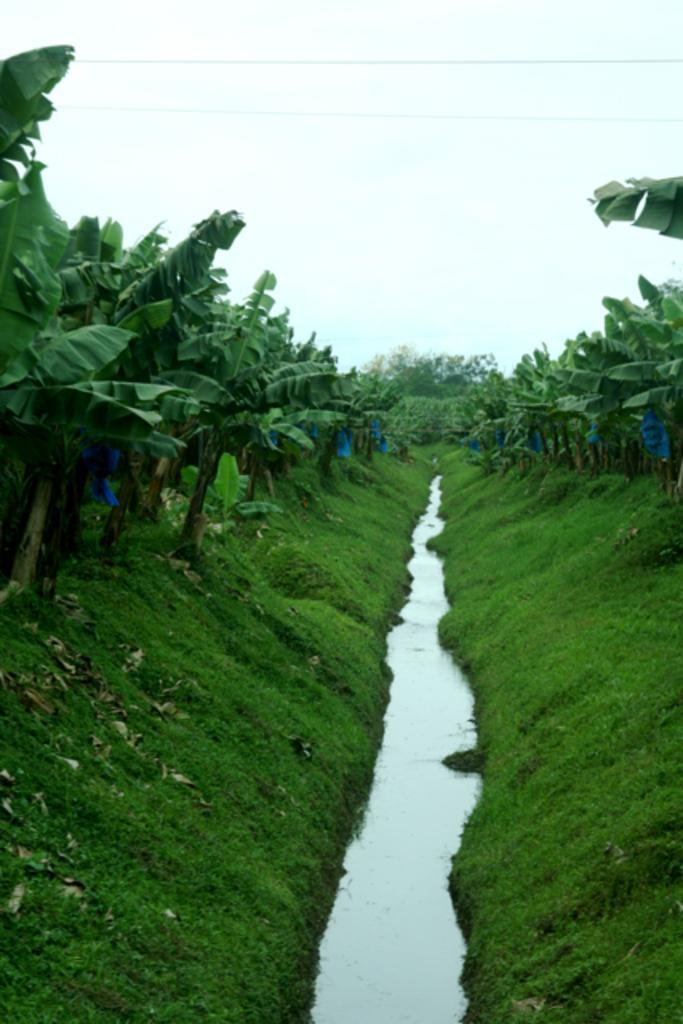In one or two sentences, can you explain what this image depicts? In this image we can see some trees, water, grass and leaves, in the background, we can see the sky. 